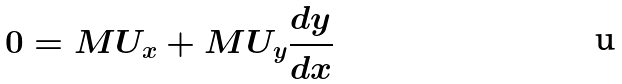Convert formula to latex. <formula><loc_0><loc_0><loc_500><loc_500>0 = M U _ { x } + M U _ { y } \frac { d y } { d x }</formula> 